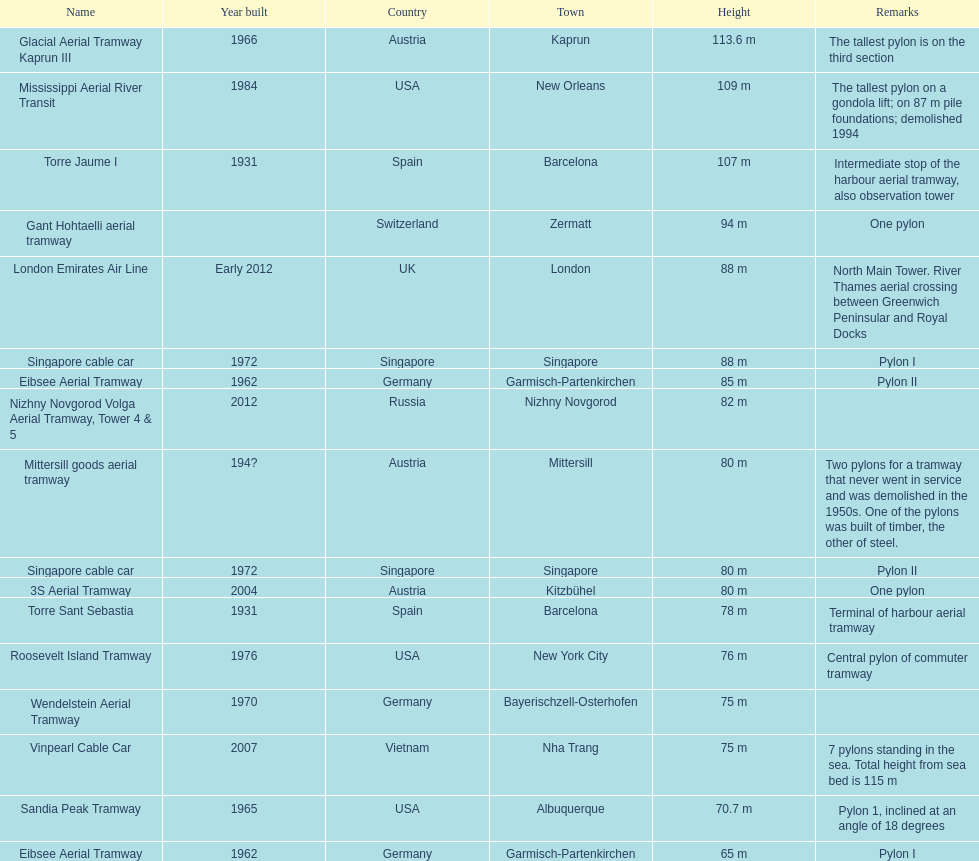What is the count of pylons that are 80 meters tall or taller? 11. 